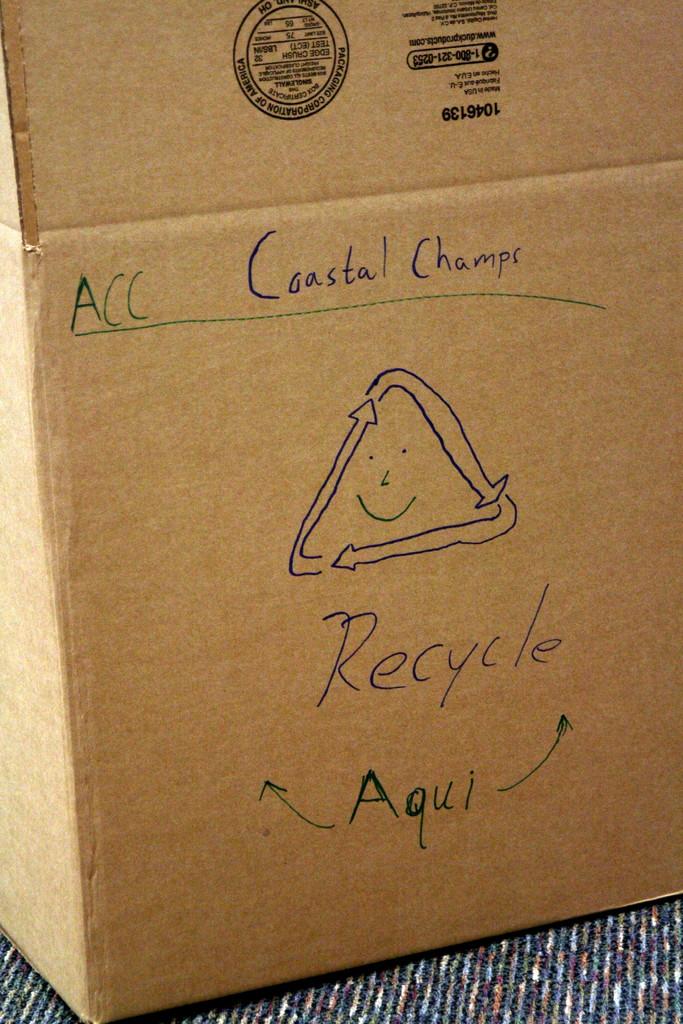What is the sign telling us to do?
Offer a very short reply. Recycle. What does it say at the top of the box?
Your answer should be compact. Acc coastal champs. 